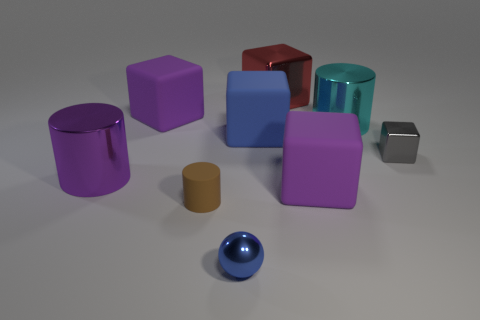What is the shape of the objects located closest to the center of the image? The object closest to the center of the image is a sphere, and it's blue in color. 